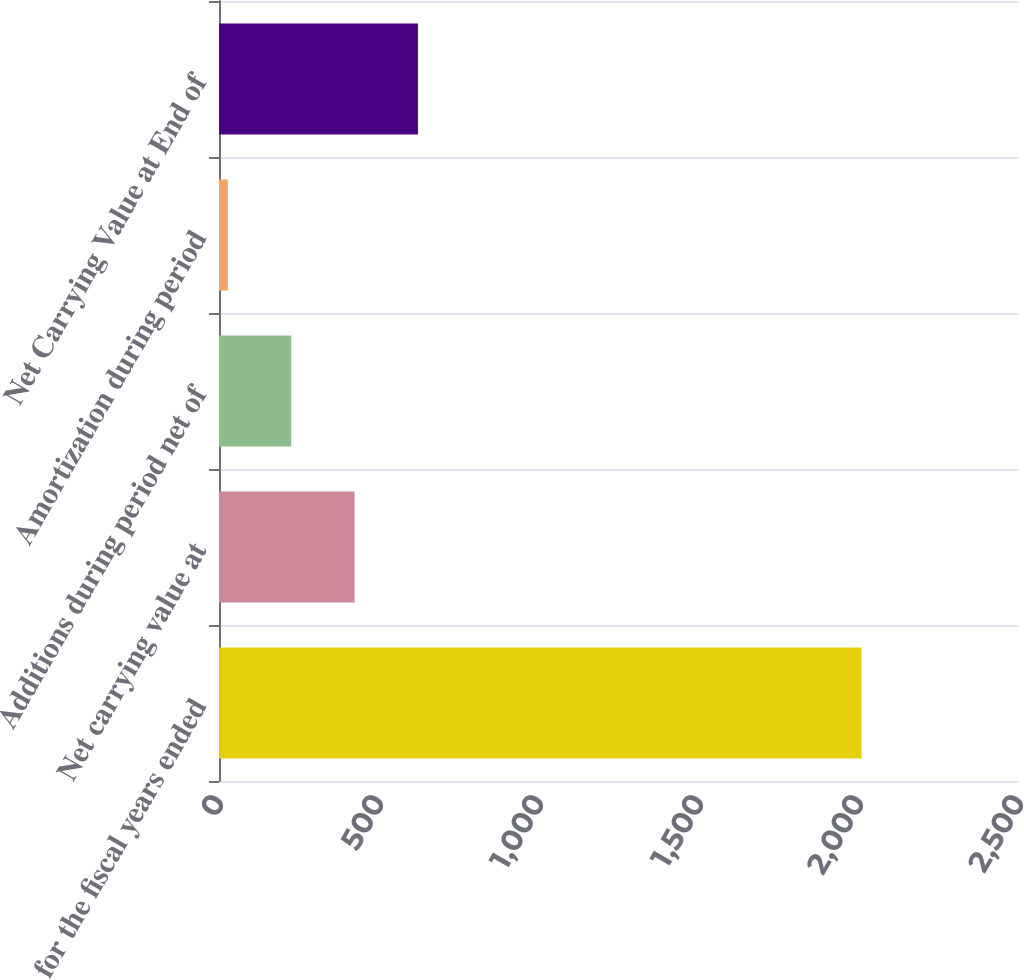Convert chart to OTSL. <chart><loc_0><loc_0><loc_500><loc_500><bar_chart><fcel>for the fiscal years ended<fcel>Net carrying value at<fcel>Additions during period net of<fcel>Amortization during period<fcel>Net Carrying Value at End of<nl><fcel>2008<fcel>423.68<fcel>225.64<fcel>27.6<fcel>621.72<nl></chart> 